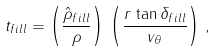<formula> <loc_0><loc_0><loc_500><loc_500>t _ { f i l l } = \left ( \frac { \hat { \rho } _ { f i l l } } { \rho } \right ) \, \left ( \frac { r \, \tan \delta _ { f i l l } } { v _ { \theta } } \right ) \, ,</formula> 